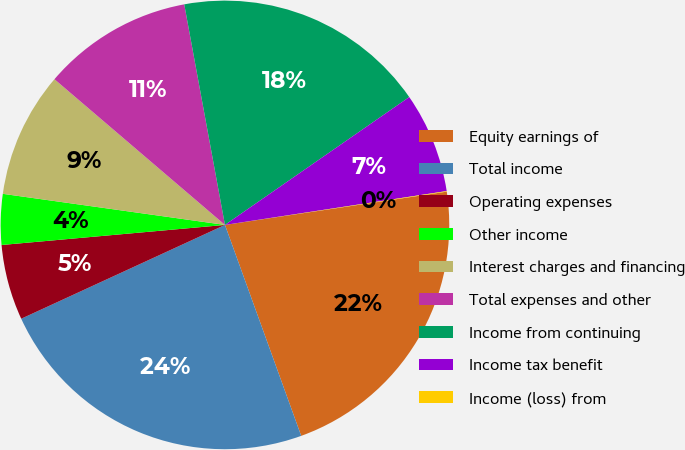Convert chart to OTSL. <chart><loc_0><loc_0><loc_500><loc_500><pie_chart><fcel>Equity earnings of<fcel>Total income<fcel>Operating expenses<fcel>Other income<fcel>Interest charges and financing<fcel>Total expenses and other<fcel>Income from continuing<fcel>Income tax benefit<fcel>Income (loss) from<nl><fcel>21.85%<fcel>23.65%<fcel>5.44%<fcel>3.64%<fcel>9.04%<fcel>10.84%<fcel>18.25%<fcel>7.24%<fcel>0.04%<nl></chart> 